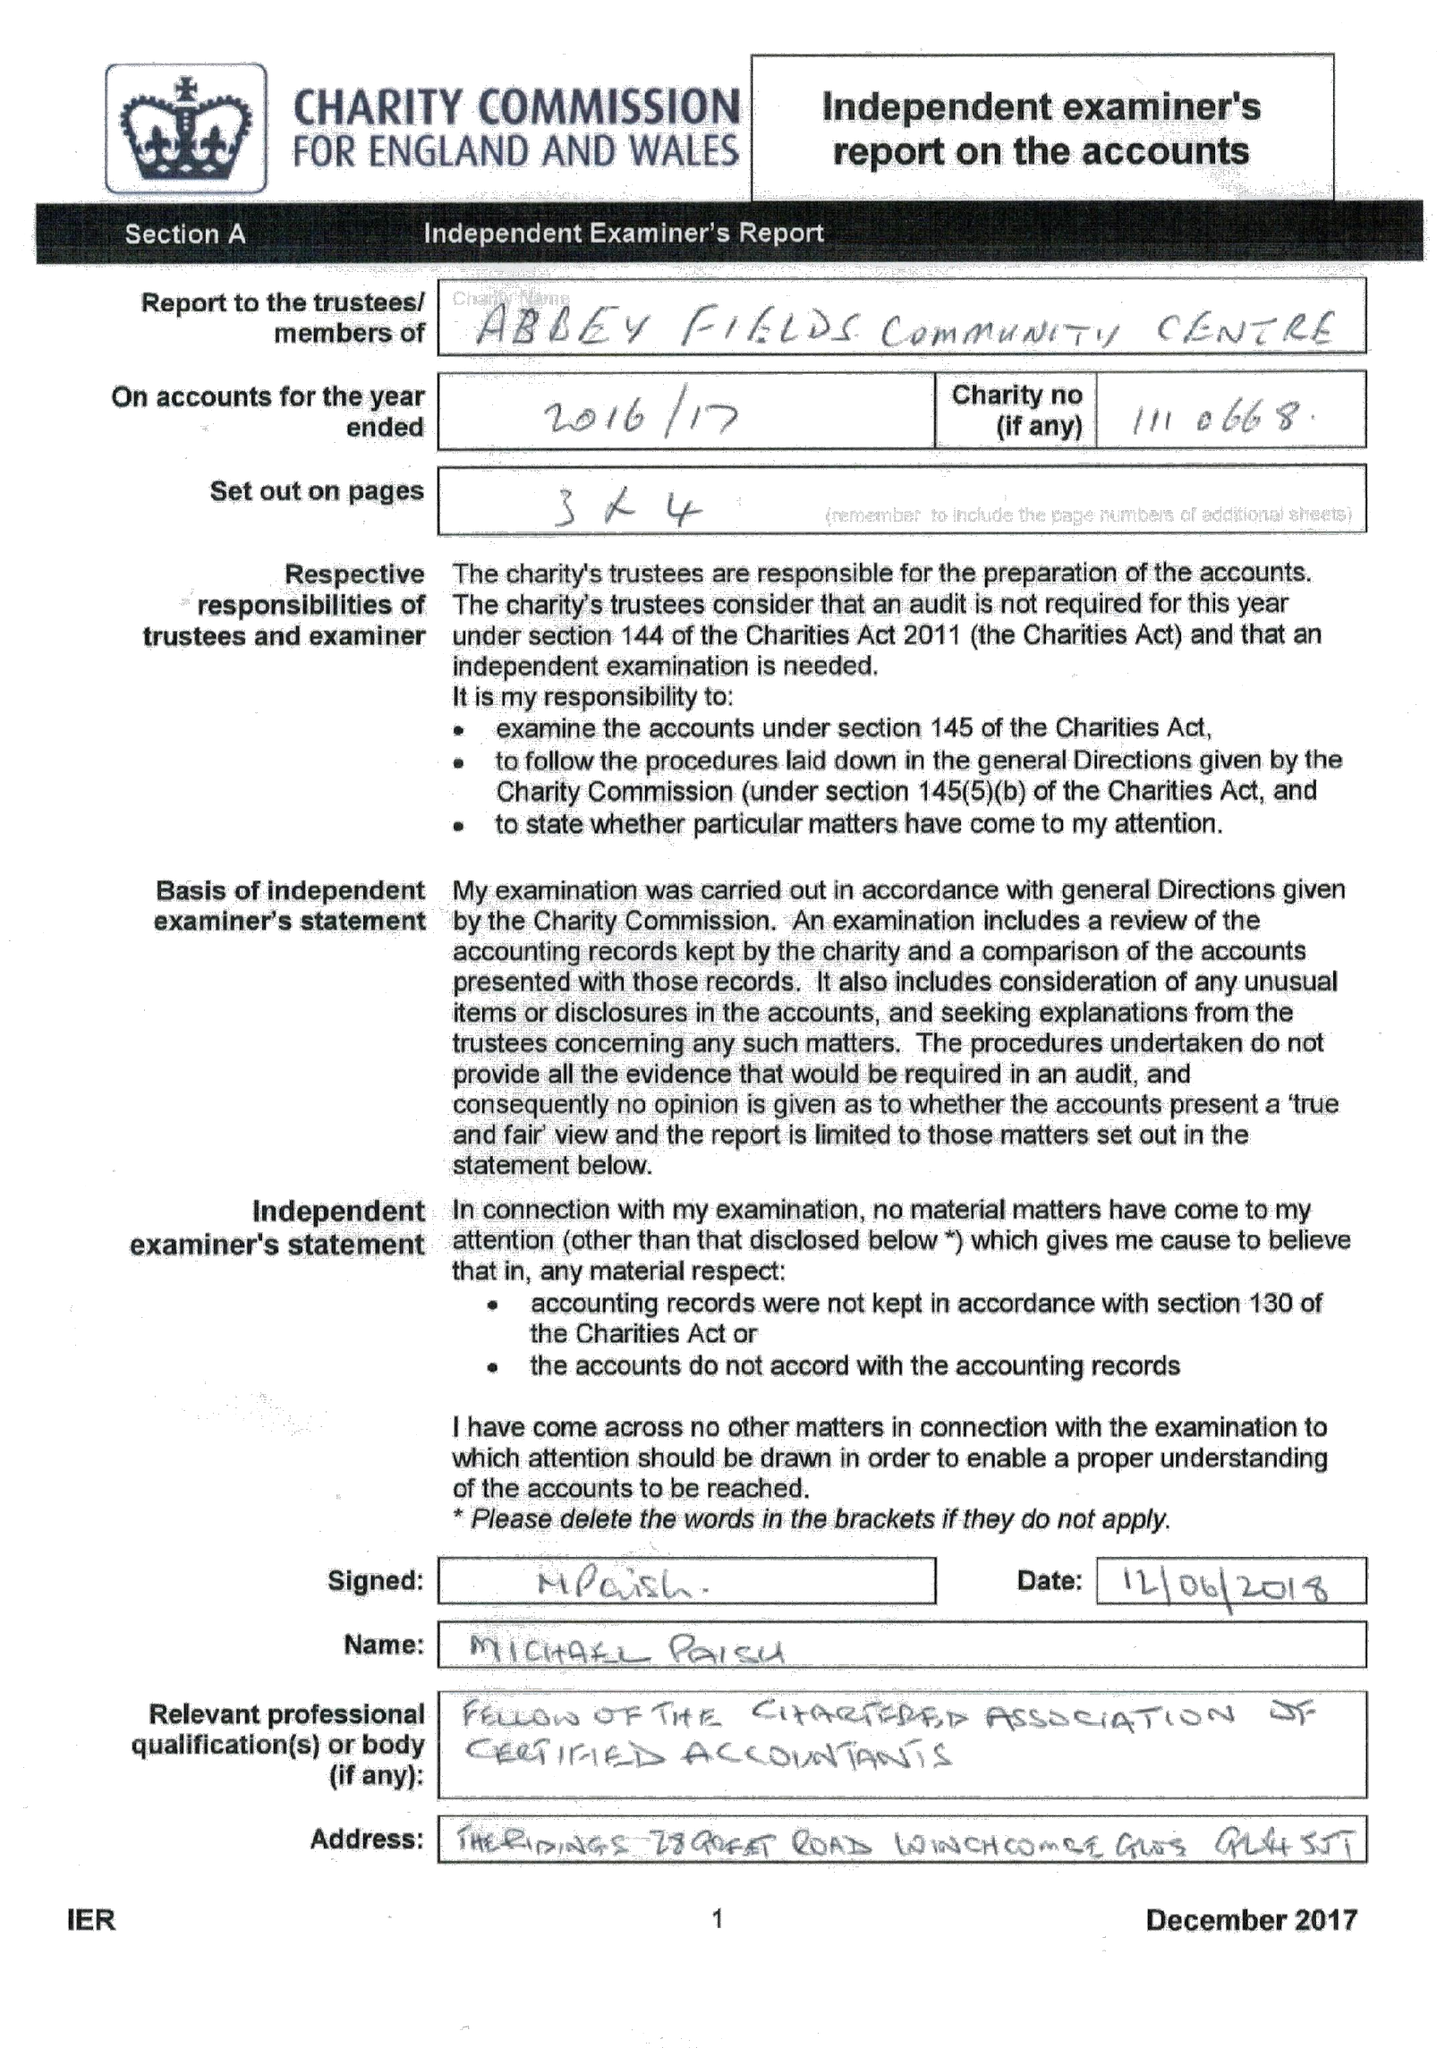What is the value for the spending_annually_in_british_pounds?
Answer the question using a single word or phrase. 17834.00 